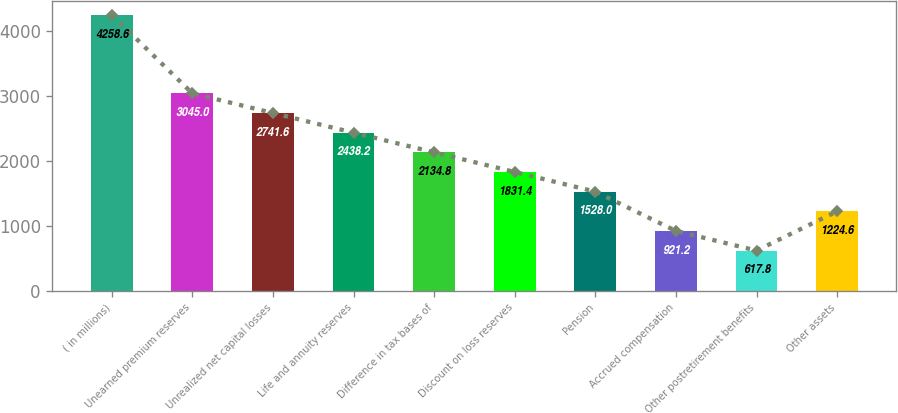Convert chart to OTSL. <chart><loc_0><loc_0><loc_500><loc_500><bar_chart><fcel>( in millions)<fcel>Unearned premium reserves<fcel>Unrealized net capital losses<fcel>Life and annuity reserves<fcel>Difference in tax bases of<fcel>Discount on loss reserves<fcel>Pension<fcel>Accrued compensation<fcel>Other postretirement benefits<fcel>Other assets<nl><fcel>4258.6<fcel>3045<fcel>2741.6<fcel>2438.2<fcel>2134.8<fcel>1831.4<fcel>1528<fcel>921.2<fcel>617.8<fcel>1224.6<nl></chart> 